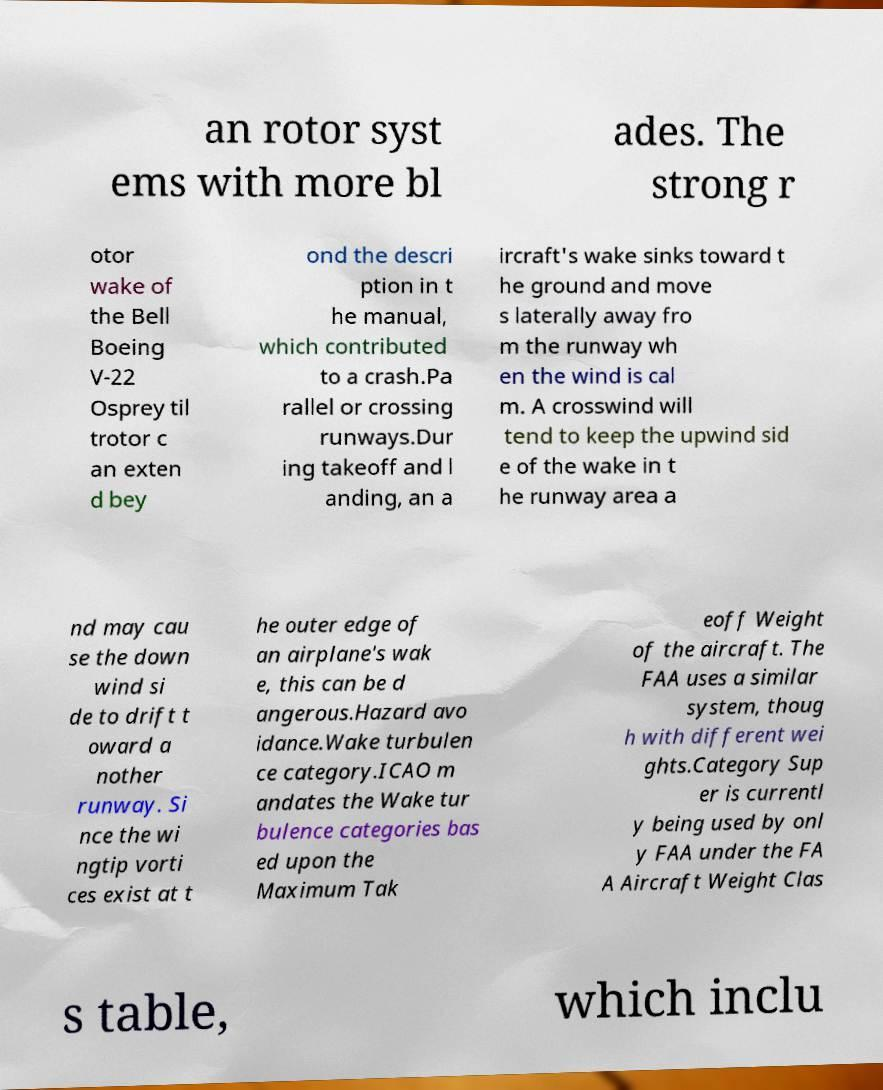What messages or text are displayed in this image? I need them in a readable, typed format. an rotor syst ems with more bl ades. The strong r otor wake of the Bell Boeing V-22 Osprey til trotor c an exten d bey ond the descri ption in t he manual, which contributed to a crash.Pa rallel or crossing runways.Dur ing takeoff and l anding, an a ircraft's wake sinks toward t he ground and move s laterally away fro m the runway wh en the wind is cal m. A crosswind will tend to keep the upwind sid e of the wake in t he runway area a nd may cau se the down wind si de to drift t oward a nother runway. Si nce the wi ngtip vorti ces exist at t he outer edge of an airplane's wak e, this can be d angerous.Hazard avo idance.Wake turbulen ce category.ICAO m andates the Wake tur bulence categories bas ed upon the Maximum Tak eoff Weight of the aircraft. The FAA uses a similar system, thoug h with different wei ghts.Category Sup er is currentl y being used by onl y FAA under the FA A Aircraft Weight Clas s table, which inclu 